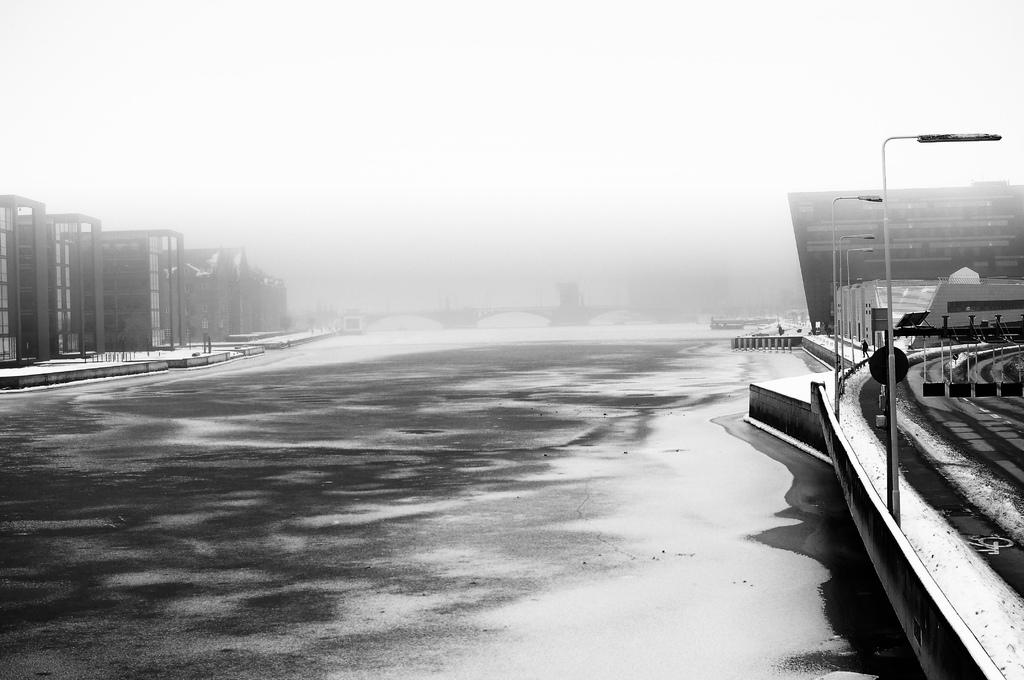What is the main subject of the image? The image depicts a road. What can be seen on the right side of the road? There are buildings on the right side of the road. What is visible at the top of the image? The sky is visible at the top of the image. How would you describe the sky in the image? The sky appears to be foggy. How many stars can be seen in the image? There are no stars visible in the image, as it depicts a road with buildings and a foggy sky. 